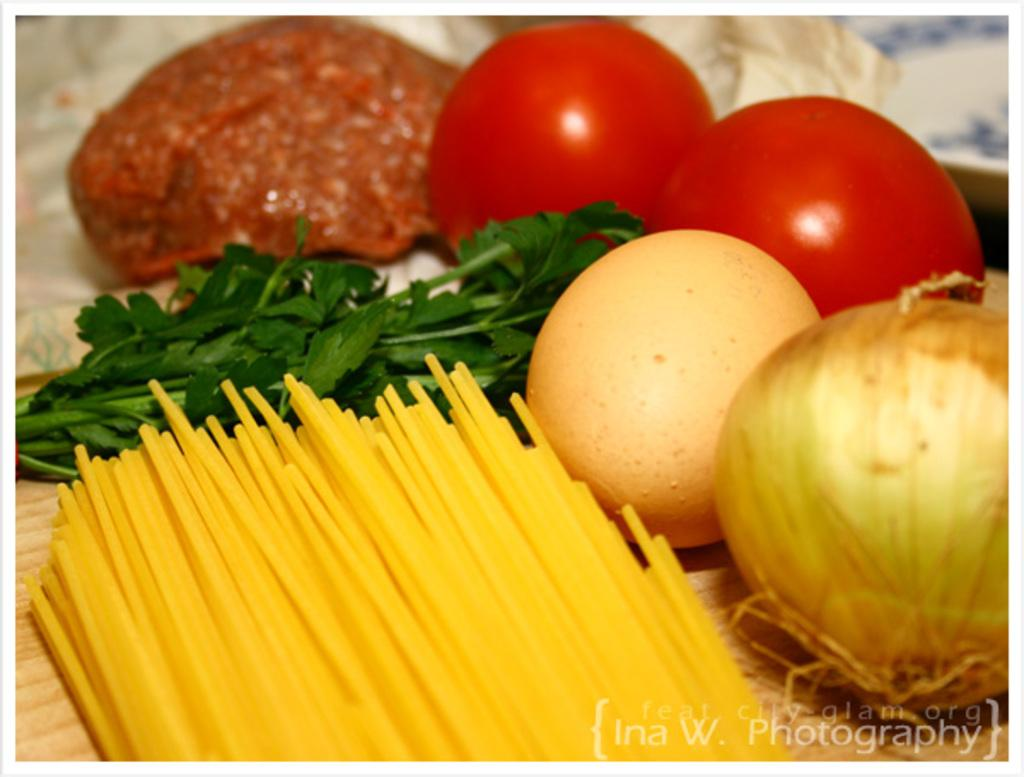What type of food is visible in the image? There is raw meat, vegetables, an egg, and spaghetti in the image. What other items can be seen in the image? There are leaves in the image. What surface is visible in the image? The wooden surface is present in the image. What type of yard can be seen in the image? There is no yard present in the image; it features food items and a wooden surface. What kind of pleasure can be derived from the image? The image does not depict a situation or activity that would evoke pleasure; it is a still life of food items and a wooden surface. 